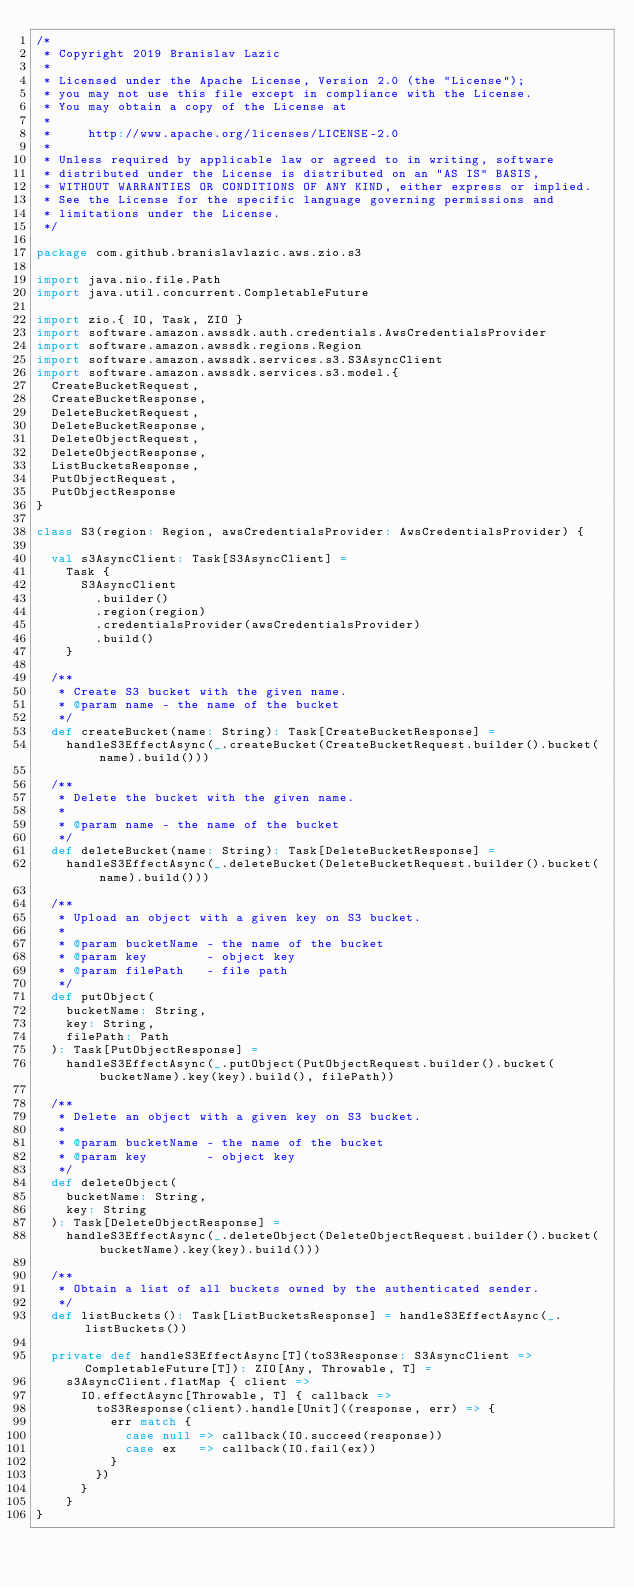Convert code to text. <code><loc_0><loc_0><loc_500><loc_500><_Scala_>/*
 * Copyright 2019 Branislav Lazic
 *
 * Licensed under the Apache License, Version 2.0 (the "License");
 * you may not use this file except in compliance with the License.
 * You may obtain a copy of the License at
 *
 *     http://www.apache.org/licenses/LICENSE-2.0
 *
 * Unless required by applicable law or agreed to in writing, software
 * distributed under the License is distributed on an "AS IS" BASIS,
 * WITHOUT WARRANTIES OR CONDITIONS OF ANY KIND, either express or implied.
 * See the License for the specific language governing permissions and
 * limitations under the License.
 */

package com.github.branislavlazic.aws.zio.s3

import java.nio.file.Path
import java.util.concurrent.CompletableFuture

import zio.{ IO, Task, ZIO }
import software.amazon.awssdk.auth.credentials.AwsCredentialsProvider
import software.amazon.awssdk.regions.Region
import software.amazon.awssdk.services.s3.S3AsyncClient
import software.amazon.awssdk.services.s3.model.{
  CreateBucketRequest,
  CreateBucketResponse,
  DeleteBucketRequest,
  DeleteBucketResponse,
  DeleteObjectRequest,
  DeleteObjectResponse,
  ListBucketsResponse,
  PutObjectRequest,
  PutObjectResponse
}

class S3(region: Region, awsCredentialsProvider: AwsCredentialsProvider) {

  val s3AsyncClient: Task[S3AsyncClient] =
    Task {
      S3AsyncClient
        .builder()
        .region(region)
        .credentialsProvider(awsCredentialsProvider)
        .build()
    }

  /**
   * Create S3 bucket with the given name.
   * @param name - the name of the bucket
   */
  def createBucket(name: String): Task[CreateBucketResponse] =
    handleS3EffectAsync(_.createBucket(CreateBucketRequest.builder().bucket(name).build()))

  /**
   * Delete the bucket with the given name.
   *
   * @param name - the name of the bucket
   */
  def deleteBucket(name: String): Task[DeleteBucketResponse] =
    handleS3EffectAsync(_.deleteBucket(DeleteBucketRequest.builder().bucket(name).build()))

  /**
   * Upload an object with a given key on S3 bucket.
   *
   * @param bucketName - the name of the bucket
   * @param key        - object key
   * @param filePath   - file path
   */
  def putObject(
    bucketName: String,
    key: String,
    filePath: Path
  ): Task[PutObjectResponse] =
    handleS3EffectAsync(_.putObject(PutObjectRequest.builder().bucket(bucketName).key(key).build(), filePath))

  /**
   * Delete an object with a given key on S3 bucket.
   *
   * @param bucketName - the name of the bucket
   * @param key        - object key
   */
  def deleteObject(
    bucketName: String,
    key: String
  ): Task[DeleteObjectResponse] =
    handleS3EffectAsync(_.deleteObject(DeleteObjectRequest.builder().bucket(bucketName).key(key).build()))

  /**
   * Obtain a list of all buckets owned by the authenticated sender.
   */
  def listBuckets(): Task[ListBucketsResponse] = handleS3EffectAsync(_.listBuckets())

  private def handleS3EffectAsync[T](toS3Response: S3AsyncClient => CompletableFuture[T]): ZIO[Any, Throwable, T] =
    s3AsyncClient.flatMap { client =>
      IO.effectAsync[Throwable, T] { callback =>
        toS3Response(client).handle[Unit]((response, err) => {
          err match {
            case null => callback(IO.succeed(response))
            case ex   => callback(IO.fail(ex))
          }
        })
      }
    }
}
</code> 